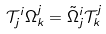<formula> <loc_0><loc_0><loc_500><loc_500>\mathcal { T } _ { j } ^ { i } \Omega _ { k } ^ { j } = \tilde { \Omega } _ { j } ^ { i } \mathcal { T } _ { k } ^ { j }</formula> 